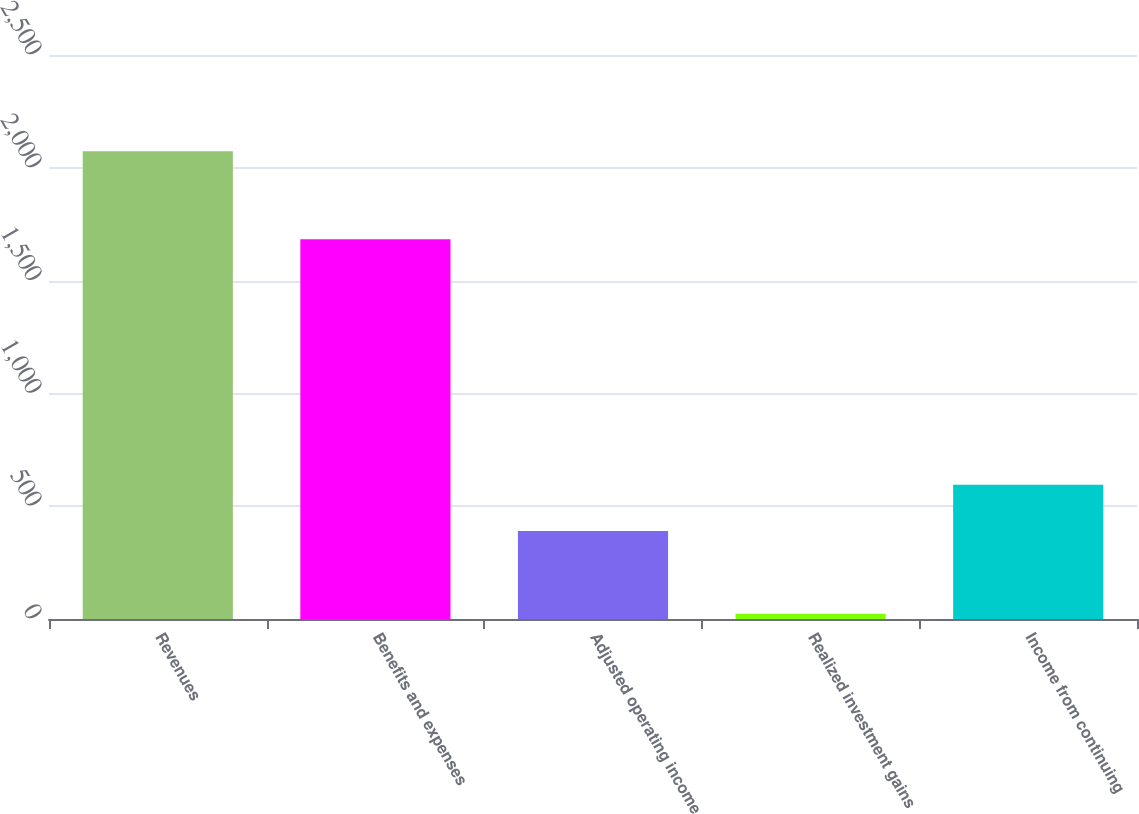<chart> <loc_0><loc_0><loc_500><loc_500><bar_chart><fcel>Revenues<fcel>Benefits and expenses<fcel>Adjusted operating income<fcel>Realized investment gains<fcel>Income from continuing<nl><fcel>2073<fcel>1683<fcel>390<fcel>23<fcel>595<nl></chart> 